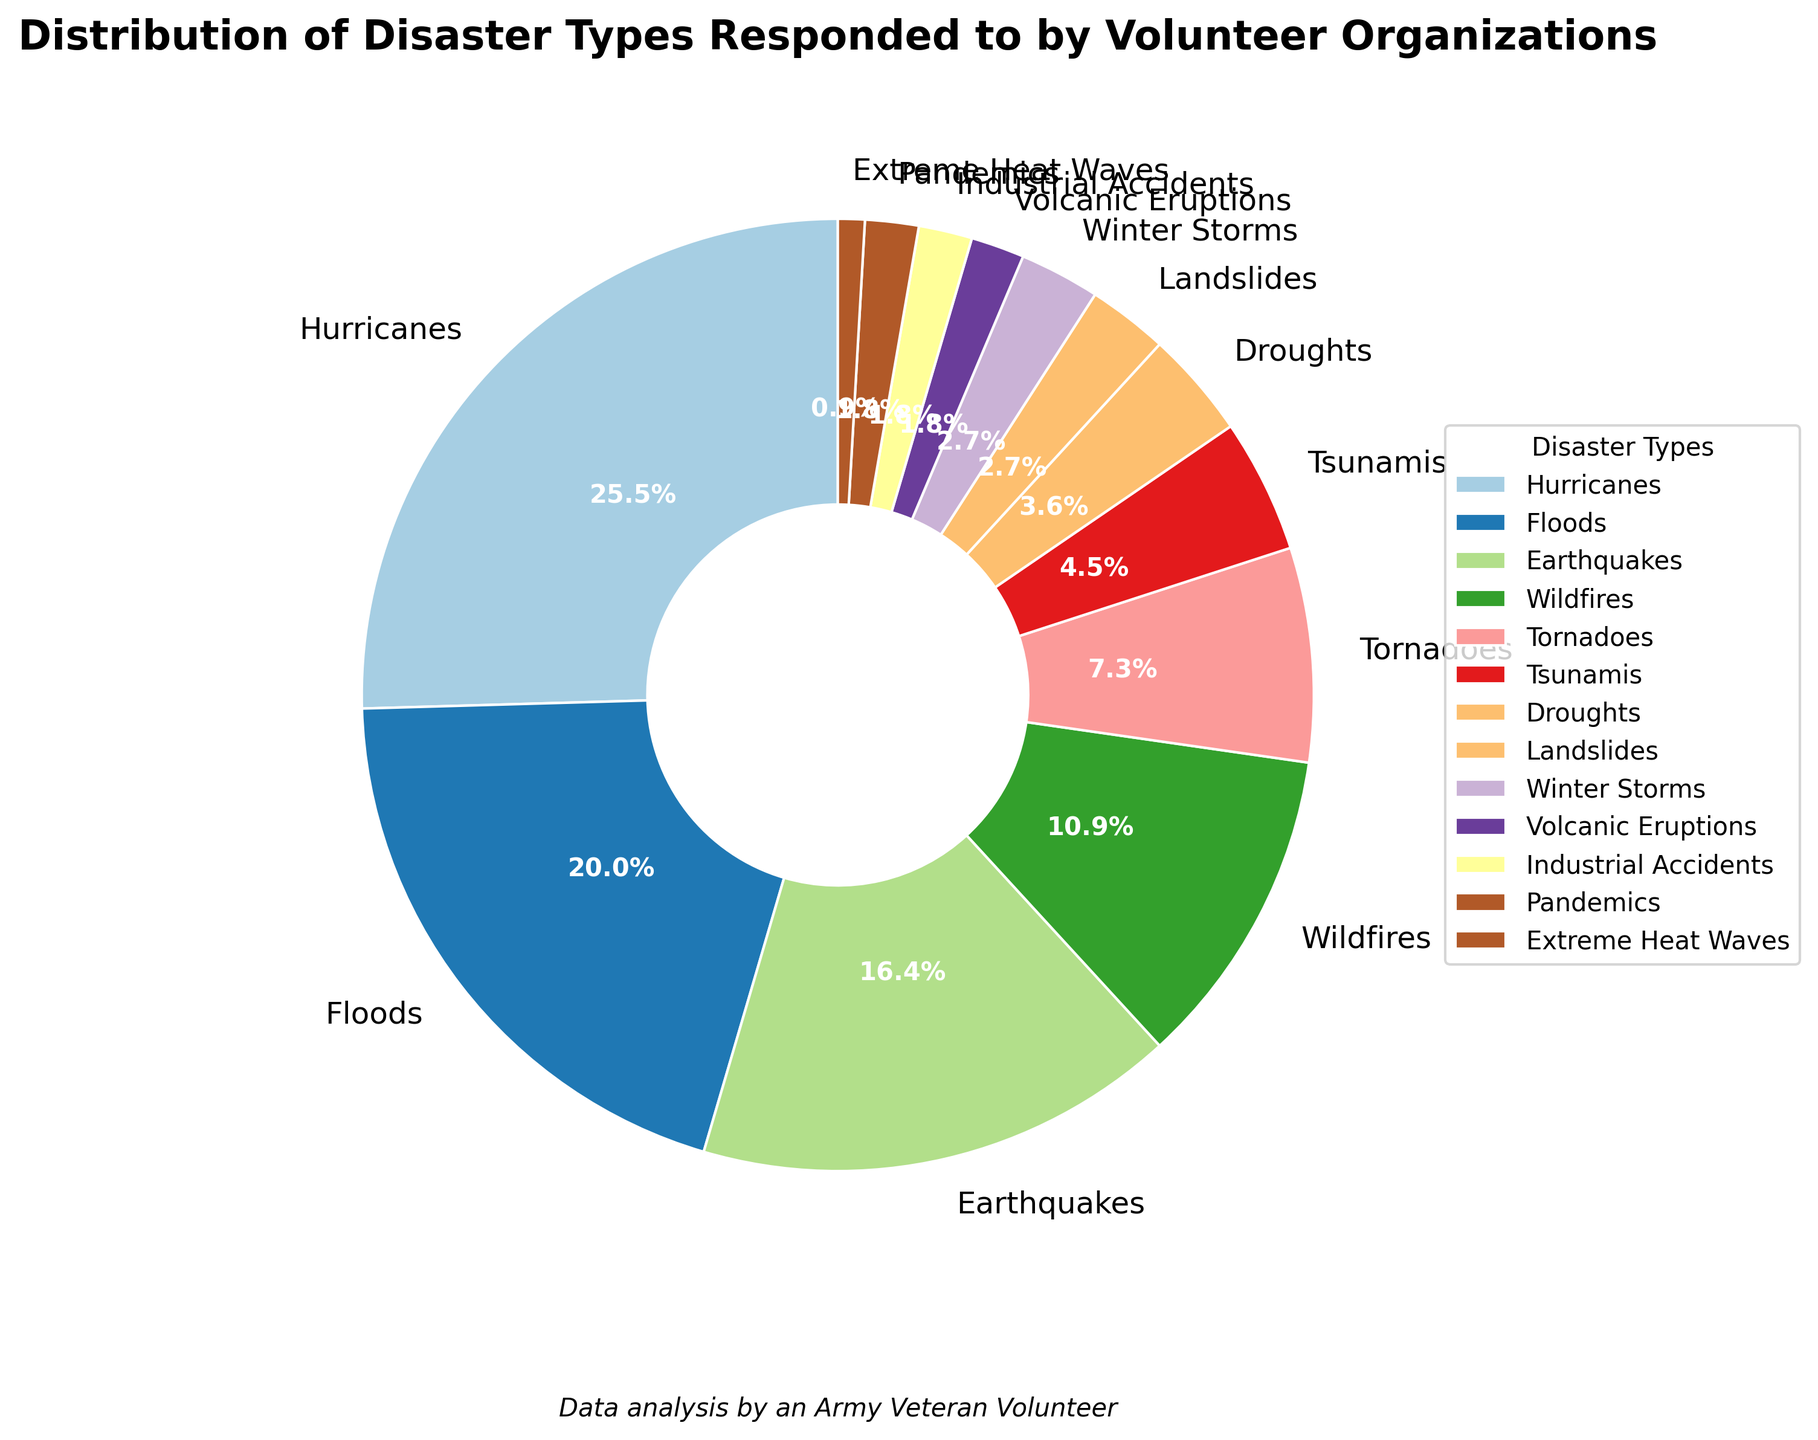What is the most common disaster type responded to by volunteer organizations? The pie chart shows that the disaster type with the largest percentage segment is "Hurricanes".
Answer: Hurricanes Which disaster type has a larger percentage, Earthquakes or Wildfires? The pie chart segments for Earthquakes and Wildfires show that Earthquakes at 18% is larger than Wildfires at 12%.
Answer: Earthquakes What is the combined percentage of Tornadoes, Tsunamis, and Droughts? To find the combined percentage, add the percentages for Tornadoes (8%), Tsunamis (5%), and Droughts (4%). So, 8% + 5% + 4% = 17%.
Answer: 17% How does the percentage for Floods compare to that for Earthquakes? The Floods segment is 22%, and the Earthquakes segment is 18%. Therefore, Floods have a higher percentage than Earthquakes.
Answer: Floods have a higher percentage Which visual segments are the smallest in the pie chart? The pie chart shows that Extreme Heat Waves, Volcanic Eruptions, Industrial Accidents, and Pandemics all have the smallest segments at 2% and 1% respectively.
Answer: Extreme Heat Waves What is the total percentage of disaster types with less than 5% response rate? Sum the percentages for disaster types with less than 5%: Tsunamis (5%), Droughts (4%), Landslides (3%), Winter Storms (3%), Volcanic Eruptions (2%), Industrial Accidents (2%), Pandemics (2%), and Extreme Heat Waves (1%). So, 5% + 4% + 3% + 3% + 2% + 2% + 2% + 1% = 22%.
Answer: 22% Which disaster types have a percentage roughly equal in size? The pie chart shows that Landslides and Winter Storms both have a segment size of 3%.
Answer: Landslides and Winter Storms How much more common are Hurricanes compared to Tornadoes? The percentage for Hurricanes is 28%, and for Tornadoes, it is 8%. The difference is 28% - 8% = 20%.
Answer: 20% more common What disaster types account for over one-third of the responses combined? Adding the two largest percentages, Hurricanes (28%) and Floods (22%), gives 28% + 22% = 50%, which is more than one-third.
Answer: Hurricanes and Floods What is the visual significance of the color differences in the pie chart? The pie chart uses different colors to clearly distinguish between each disaster type, making it easier to identify and separate the segments visually.
Answer: Clear distinction 